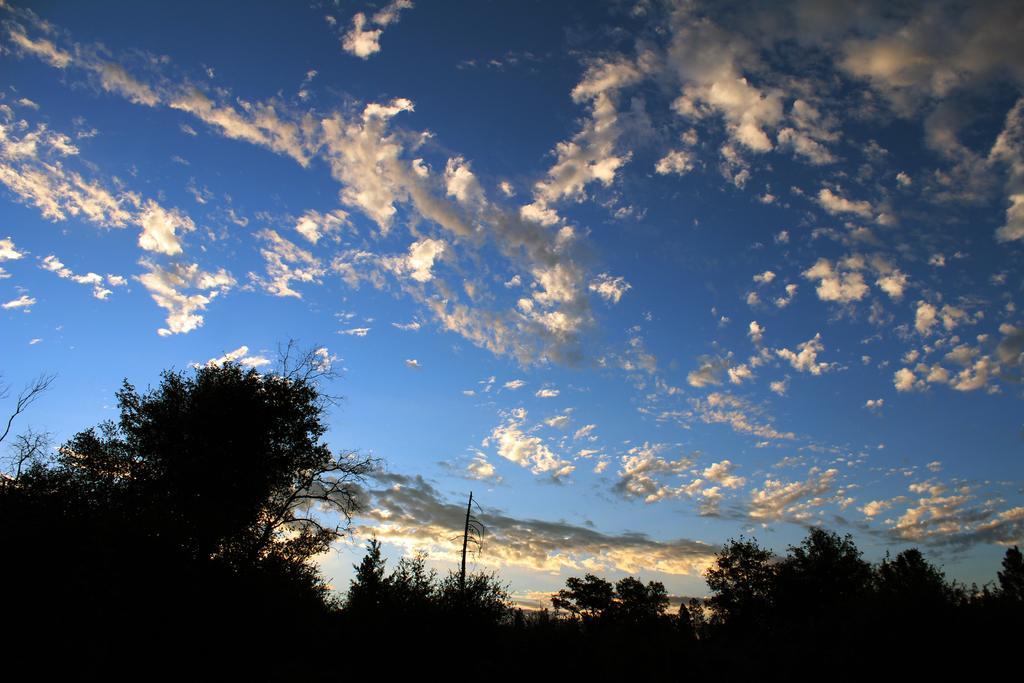In one or two sentences, can you explain what this image depicts? In this picture I can see trees, pole and sky in the background. 